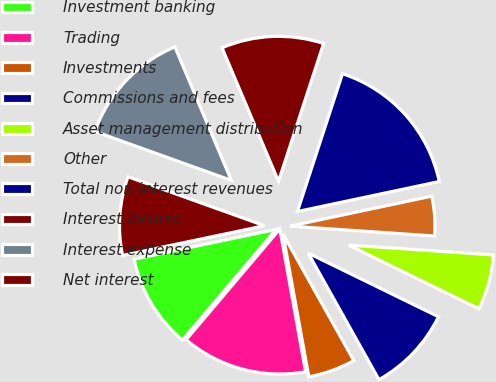Convert chart. <chart><loc_0><loc_0><loc_500><loc_500><pie_chart><fcel>Investment banking<fcel>Trading<fcel>Investments<fcel>Commissions and fees<fcel>Asset management distribution<fcel>Other<fcel>Total non-interest revenues<fcel>Interest income<fcel>Interest expense<fcel>Net interest<nl><fcel>10.53%<fcel>14.03%<fcel>5.27%<fcel>9.65%<fcel>6.15%<fcel>4.4%<fcel>16.65%<fcel>11.4%<fcel>13.15%<fcel>8.77%<nl></chart> 